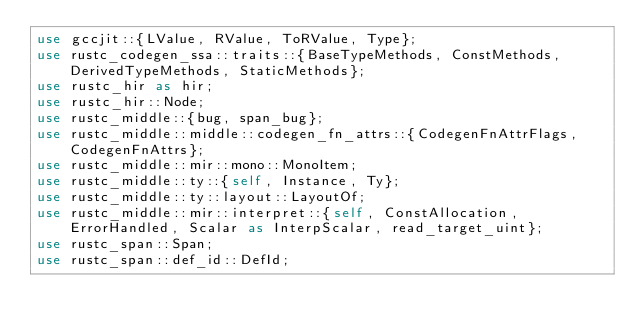<code> <loc_0><loc_0><loc_500><loc_500><_Rust_>use gccjit::{LValue, RValue, ToRValue, Type};
use rustc_codegen_ssa::traits::{BaseTypeMethods, ConstMethods, DerivedTypeMethods, StaticMethods};
use rustc_hir as hir;
use rustc_hir::Node;
use rustc_middle::{bug, span_bug};
use rustc_middle::middle::codegen_fn_attrs::{CodegenFnAttrFlags, CodegenFnAttrs};
use rustc_middle::mir::mono::MonoItem;
use rustc_middle::ty::{self, Instance, Ty};
use rustc_middle::ty::layout::LayoutOf;
use rustc_middle::mir::interpret::{self, ConstAllocation, ErrorHandled, Scalar as InterpScalar, read_target_uint};
use rustc_span::Span;
use rustc_span::def_id::DefId;</code> 